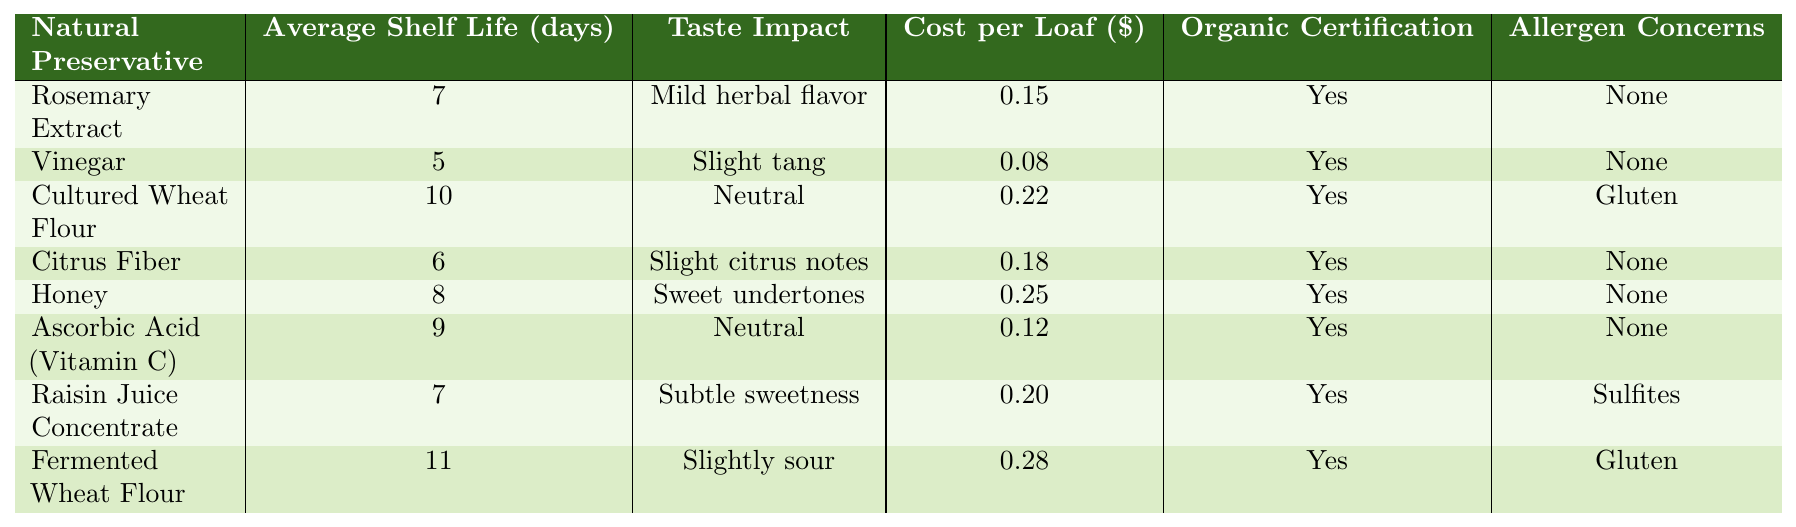What is the average shelf life of the natural preservatives listed? To find the average shelf life, sum the shelf life for all preservatives (7 + 5 + 10 + 6 + 8 + 9 + 7 + 11 = 63) and divide by the number of preservatives (8). Thus, the average shelf life is 63 / 8 = 7.875 days.
Answer: 7.875 Which natural preservative has the longest shelf life? The longest shelf life is found by comparing the average shelf life values of all preservatives. Fermented Wheat Flour has the highest value of 11 days.
Answer: Fermented Wheat Flour How much does it cost per loaf for Cultured Wheat Flour? The table lists the cost of Cultured Wheat Flour per loaf as $0.22.
Answer: $0.22 Are all ingredients organic certified? The table shows that all listed preservatives have the organic certification marked as 'Yes'.
Answer: Yes What is the taste impact of Honey as a natural preservative? According to the table, Honey has a taste impact described as "Sweet undertones".
Answer: Sweet undertones Which preservatives have allergen concerns? The table indicates that Cultured Wheat Flour, Raisin Juice Concentrate, and Fermented Wheat Flour have allergen concerns (Gluten and Sulfites).
Answer: Cultured Wheat Flour, Raisin Juice Concentrate, Fermented Wheat Flour What is the total cost per loaf for the preservatives with a shelf life greater than 7 days? First, identify preservatives with a shelf life greater than 7 days: Cultured Wheat Flour (0.22), Honey (0.25), Ascorbic Acid (0.12), Fermented Wheat Flour (0.28). The total cost is calculated as (0.22 + 0.25 + 0.12 + 0.28 = 0.87).
Answer: $0.87 Which natural preservative has the lowest cost? By inspecting the costs provided for each ingredient, Vinegar has the lowest cost of $0.08 per loaf.
Answer: Vinegar Is there any natural preservative without any allergen concerns? Yes, the table shows Rosemary Extract, Vinegar, Citrus Fiber, Honey, and Ascorbic Acid have no allergens listed, implying they have none.
Answer: Yes What is the difference in average shelf life between Fermented Wheat Flour and Vinegar? The shelf life of Fermented Wheat Flour is 11 days, and Vinegar is 5 days. The difference is calculated as 11 - 5 = 6 days.
Answer: 6 days 